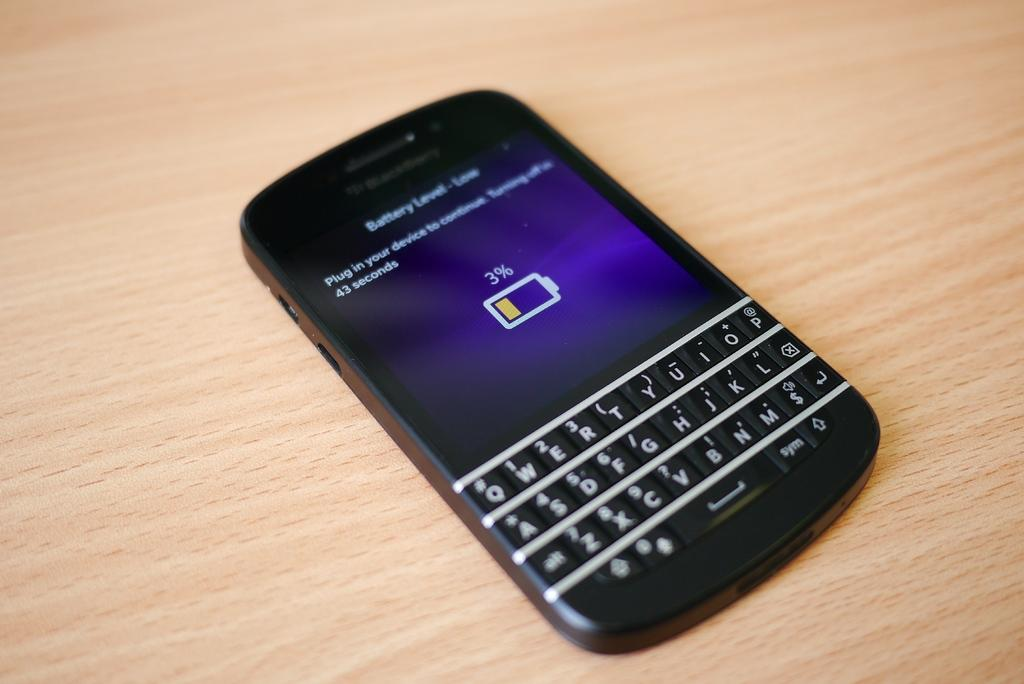<image>
Relay a brief, clear account of the picture shown. the 'battery level - low' screen on a black blackberry phone 